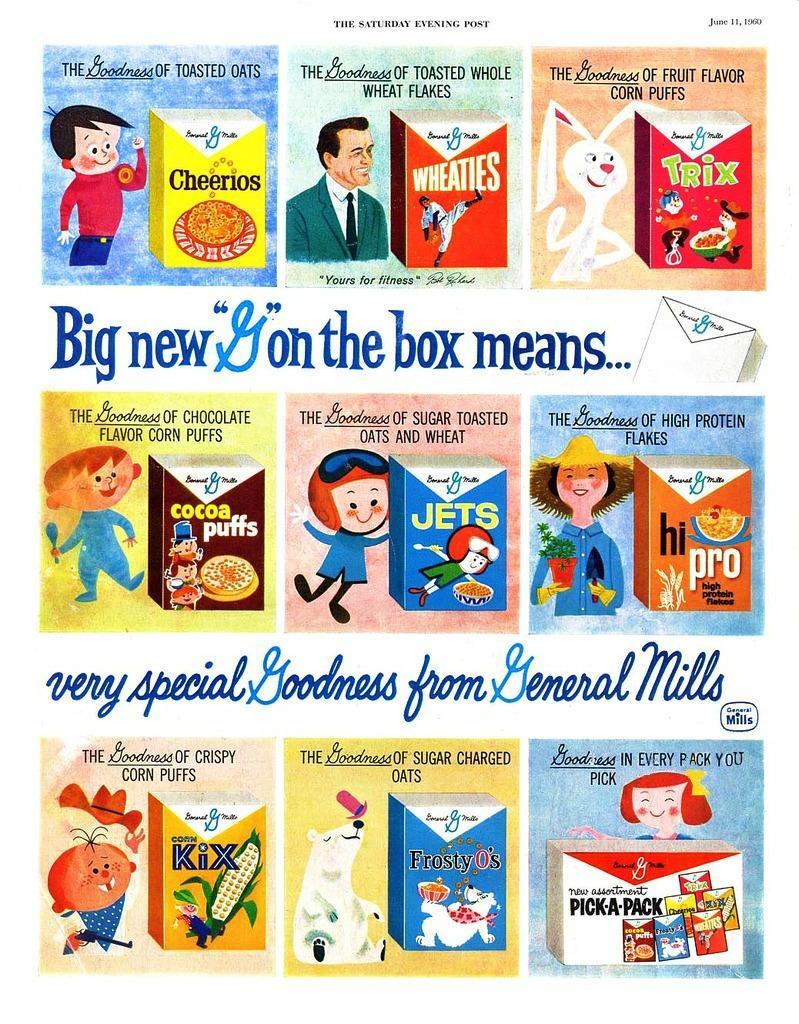Can you describe this image briefly? In this image we can see a poster. On the poster, we can see the cartons, boxes and some text. 